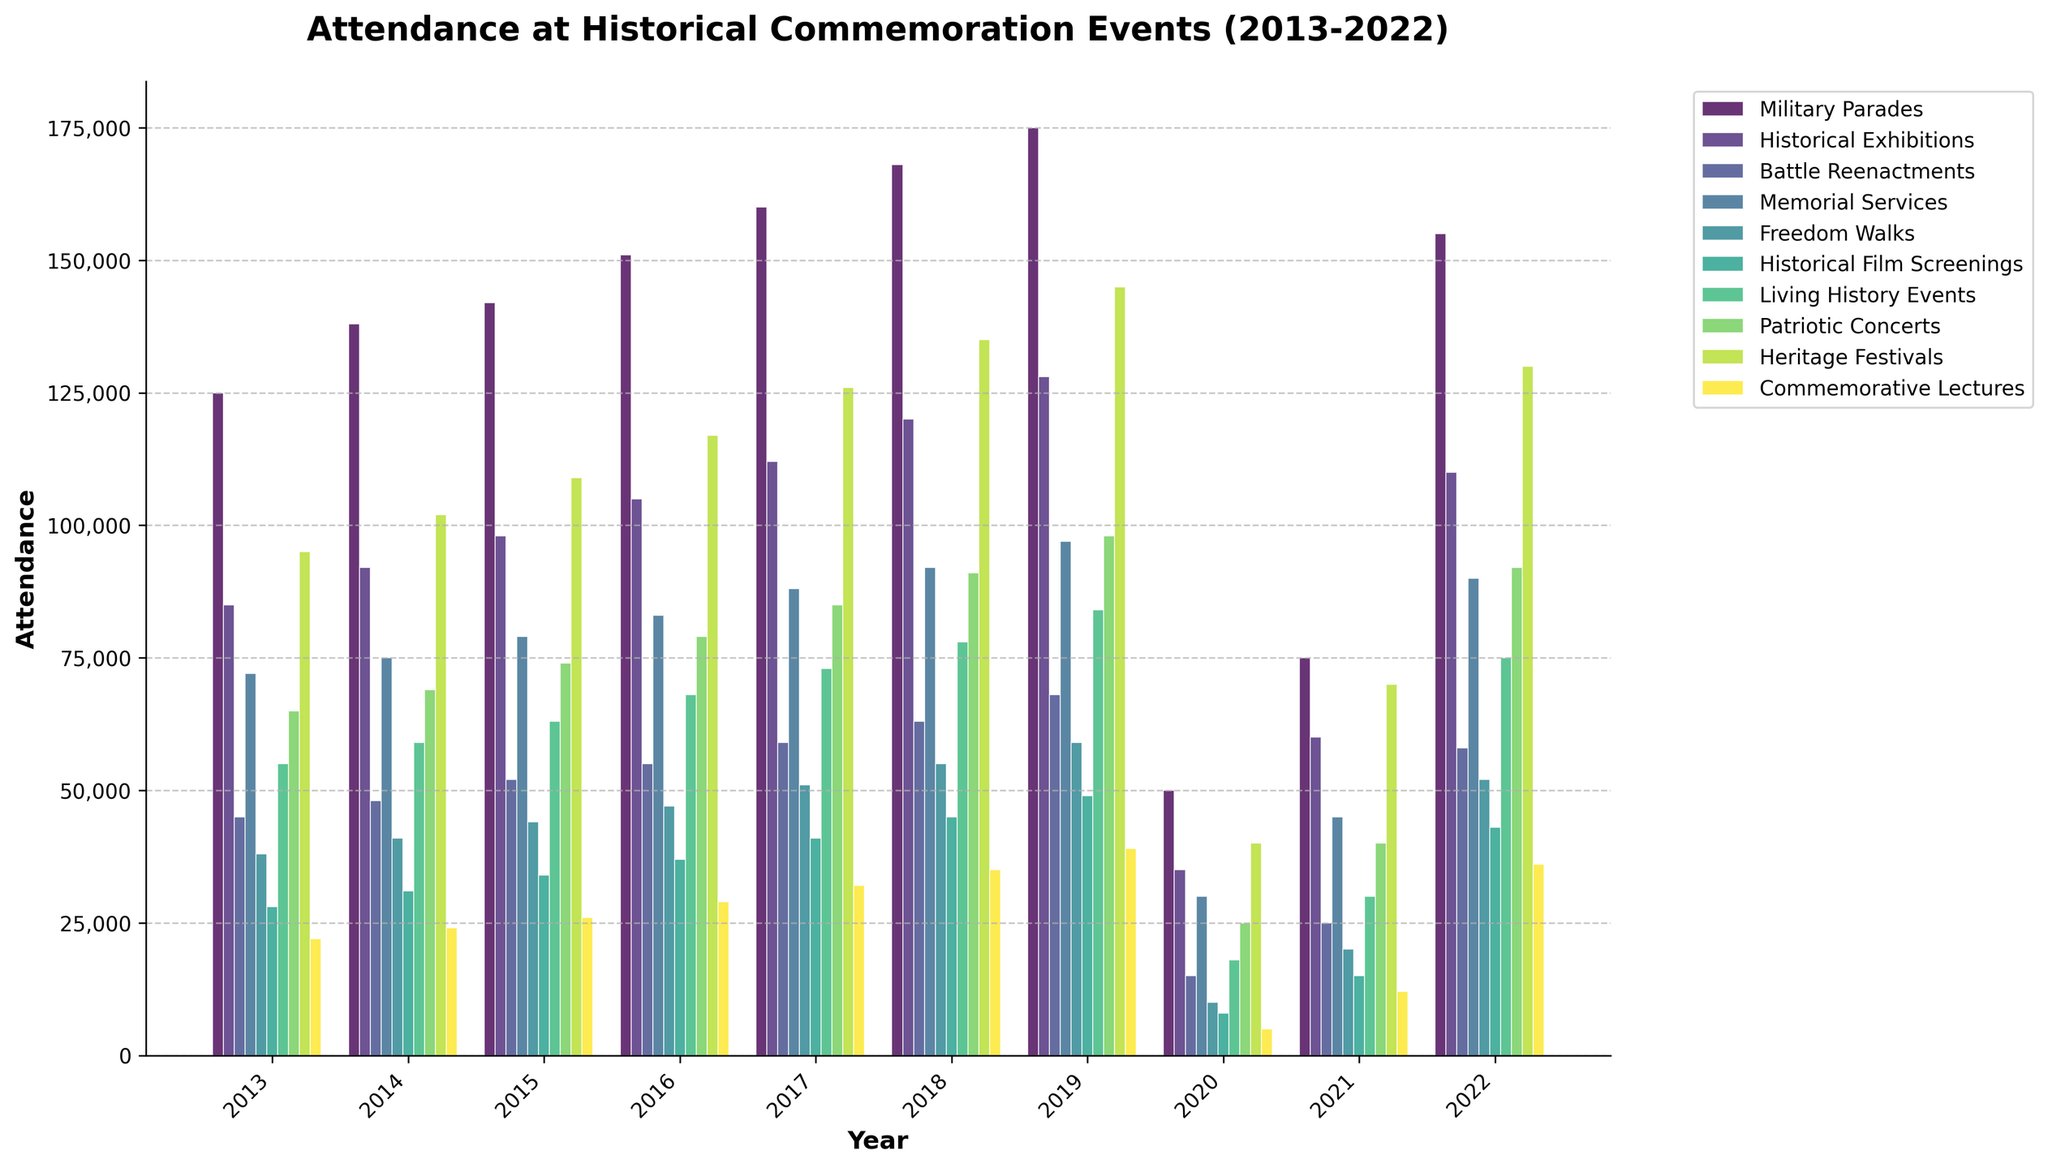What are the highest and lowest attendance numbers across all events in 2022? To determine the highest and lowest attendance numbers in 2022, compare the values across all event types for that year. The highest is 155,000 (Military Parades) and the lowest is 36,000 (Commemorative Lectures).
Answer: Highest: 155,000; Lowest: 36,000 Which event type had the most significant drop in attendance between 2019 and 2020? Compare the differences in attendance for each event type between 2019 and 2020. Military Parades had the most significant drop from 175,000 to 50,000, a reduction of 125,000.
Answer: Military Parades What's the average attendance for Historical Exhibitions from 2013 to 2022? Sum the attendance numbers for Historical Exhibitions over the ten years and divide by the number of years: (85,000 + 92,000 + 98,000 + 105,000 + 112,000 + 120,000 + 128,000 + 35,000 + 60,000 + 110,000) / 10 = 94,500.
Answer: 94,500 Which year saw the highest combined attendance for Memorial Services and Patriotic Concerts? Add the attendance for Memorial Services and Patriotic Concerts for each year, then compare to find the highest combined total. In 2019, Memorial Services (97,000) and Patriotic Concerts (98,000) combined for 195,000, the highest of any year.
Answer: 2019 In which year did Living History Events see the lowest attendance, and what was the number? Scan the attendance numbers for Living History Events and identify the year with the lowest value, which is 2020 with 18,000 attendees.
Answer: 2020, 18,000 How much did overall attendance for Heritage Festivals change from 2018 to 2022? Calculate the difference in Heritage Festivals' attendance between 2018 and 2022: 130,000 (2022) - 135,000 (2018), which is a decrease of 5,000.
Answer: -5,000 What is the trend for Freedom Walks attendance from 2013 to 2022? Observe the visual trend of Freedom Walks attendance over the years. The attendance generally increases till 2019 and then drops in 2020 and 2021, with a recovery in 2022.
Answer: Increasing till 2019, dropping in 2020-2021, recovering in 2022 During which year did Historical Film Screenings have more attendance than Battle Reenactments? Compare the attendance of Historical Film Screenings and Battle Reenactments from 2013 to 2022 to find the years where Film Screenings had higher attendance. In 2022, Historical Film Screenings (43,000) surpassed Battle Reenactments (58,000).
Answer: None 